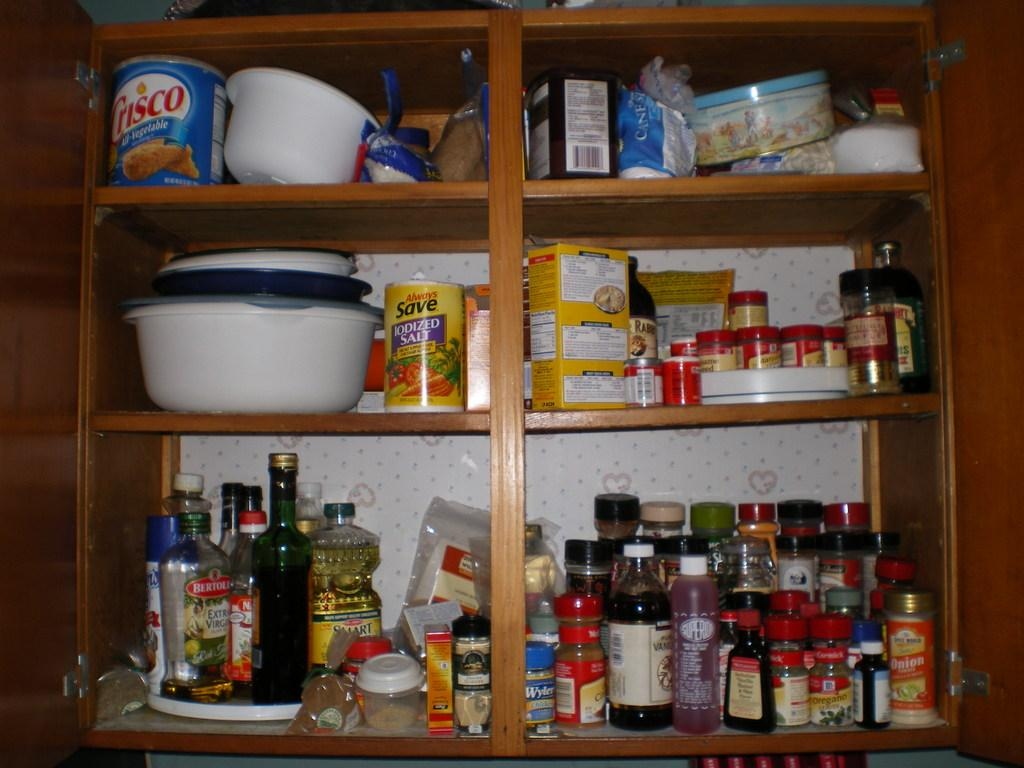What type of storage unit is visible in the image? There is an open shelf with racks in the image. What items can be seen on the racks? The racks contain bottles, containers, food packets, food boxes, and other objects. Can you describe the contents of the racks in more detail? The racks contain bottles of various sizes, containers with lids, food packets like chips or cookies, food boxes like cereal or pasta, and other miscellaneous objects. What type of book is placed on the rail in the image? There is no book or rail present in the image; it features an open shelf with racks containing various items. Can you describe the bread that is being sliced on the rail in the image? There is no bread or rail present in the image; it only contains racks with bottles, containers, food packets, food boxes, and other objects. 